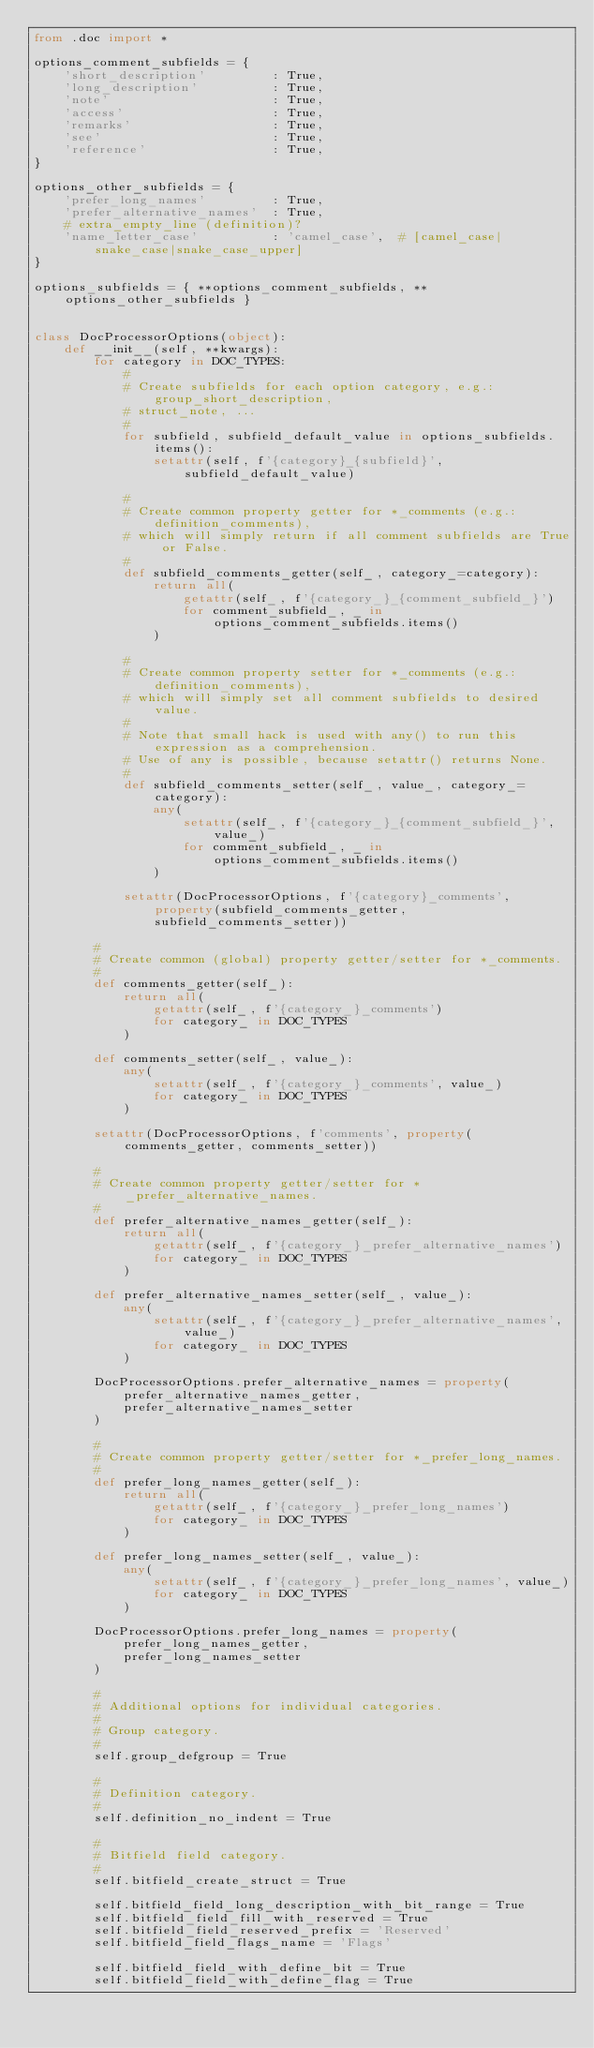<code> <loc_0><loc_0><loc_500><loc_500><_Python_>from .doc import *

options_comment_subfields = {
    'short_description'         : True,
    'long_description'          : True,
    'note'                      : True,
    'access'                    : True,
    'remarks'                   : True,
    'see'                       : True,
    'reference'                 : True,
}

options_other_subfields = {
    'prefer_long_names'         : True,
    'prefer_alternative_names'  : True,
    # extra_empty_line (definition)?
    'name_letter_case'          : 'camel_case',  # [camel_case|snake_case|snake_case_upper]
}

options_subfields = { **options_comment_subfields, **options_other_subfields }


class DocProcessorOptions(object):
    def __init__(self, **kwargs):
        for category in DOC_TYPES:
            #
            # Create subfields for each option category, e.g.: group_short_description,
            # struct_note, ...
            #
            for subfield, subfield_default_value in options_subfields.items():
                setattr(self, f'{category}_{subfield}', subfield_default_value)

            #
            # Create common property getter for *_comments (e.g.: definition_comments),
            # which will simply return if all comment subfields are True or False.
            #
            def subfield_comments_getter(self_, category_=category):
                return all(
                    getattr(self_, f'{category_}_{comment_subfield_}')
                    for comment_subfield_, _ in options_comment_subfields.items()
                )

            #
            # Create common property setter for *_comments (e.g.: definition_comments),
            # which will simply set all comment subfields to desired value.
            #
            # Note that small hack is used with any() to run this expression as a comprehension.
            # Use of any is possible, because setattr() returns None.
            #
            def subfield_comments_setter(self_, value_, category_=category):
                any(
                    setattr(self_, f'{category_}_{comment_subfield_}', value_)
                    for comment_subfield_, _ in options_comment_subfields.items()
                )

            setattr(DocProcessorOptions, f'{category}_comments', property(subfield_comments_getter, subfield_comments_setter))

        #
        # Create common (global) property getter/setter for *_comments.
        #
        def comments_getter(self_):
            return all(
                getattr(self_, f'{category_}_comments')
                for category_ in DOC_TYPES
            )

        def comments_setter(self_, value_):
            any(
                setattr(self_, f'{category_}_comments', value_)
                for category_ in DOC_TYPES
            )

        setattr(DocProcessorOptions, f'comments', property(comments_getter, comments_setter))

        #
        # Create common property getter/setter for *_prefer_alternative_names.
        #
        def prefer_alternative_names_getter(self_):
            return all(
                getattr(self_, f'{category_}_prefer_alternative_names')
                for category_ in DOC_TYPES
            )

        def prefer_alternative_names_setter(self_, value_):
            any(
                setattr(self_, f'{category_}_prefer_alternative_names', value_)
                for category_ in DOC_TYPES
            )

        DocProcessorOptions.prefer_alternative_names = property(
            prefer_alternative_names_getter,
            prefer_alternative_names_setter
        )

        #
        # Create common property getter/setter for *_prefer_long_names.
        #
        def prefer_long_names_getter(self_):
            return all(
                getattr(self_, f'{category_}_prefer_long_names')
                for category_ in DOC_TYPES
            )

        def prefer_long_names_setter(self_, value_):
            any(
                setattr(self_, f'{category_}_prefer_long_names', value_)
                for category_ in DOC_TYPES
            )

        DocProcessorOptions.prefer_long_names = property(
            prefer_long_names_getter,
            prefer_long_names_setter
        )

        #
        # Additional options for individual categories.
        #
        # Group category.
        #
        self.group_defgroup = True

        #
        # Definition category.
        #
        self.definition_no_indent = True

        #
        # Bitfield field category.
        #
        self.bitfield_create_struct = True

        self.bitfield_field_long_description_with_bit_range = True
        self.bitfield_field_fill_with_reserved = True
        self.bitfield_field_reserved_prefix = 'Reserved'
        self.bitfield_field_flags_name = 'Flags'

        self.bitfield_field_with_define_bit = True
        self.bitfield_field_with_define_flag = True</code> 